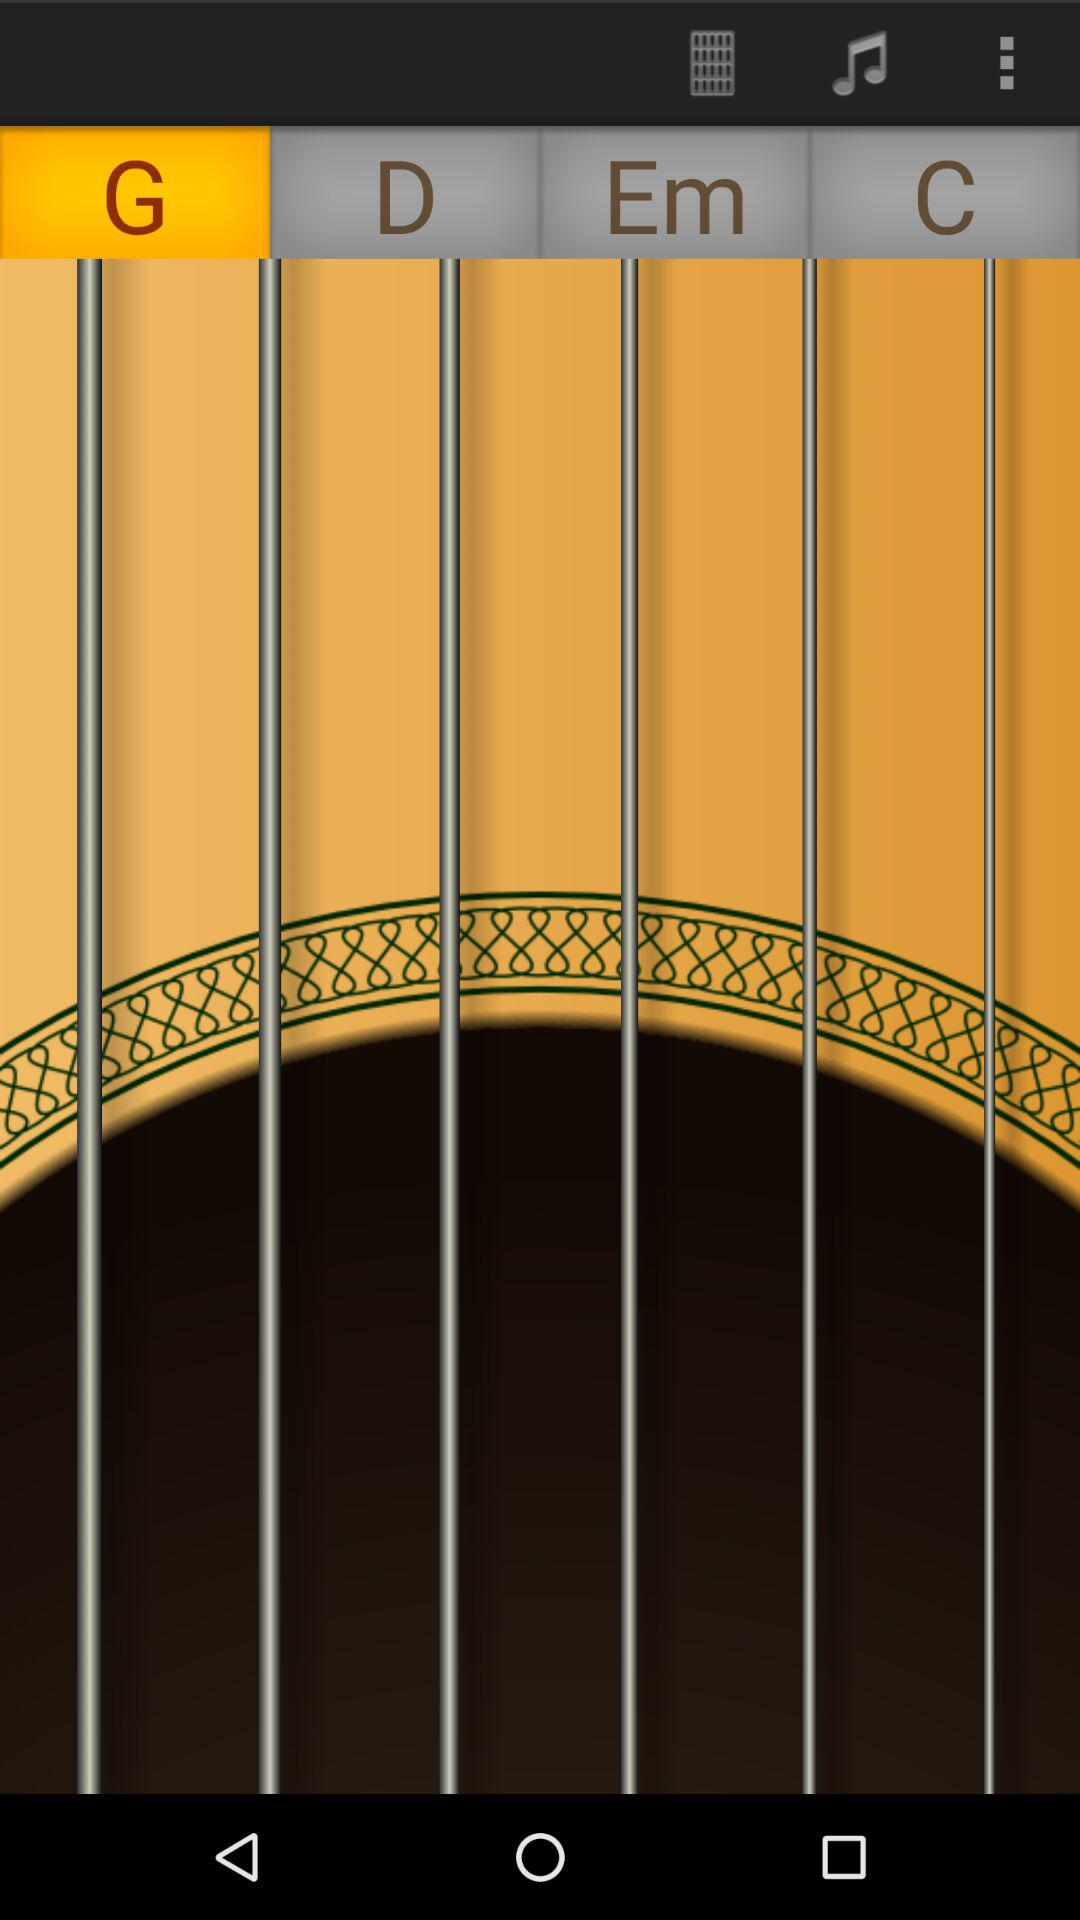What is the selected alphabet? The selected alphabet is "G". 